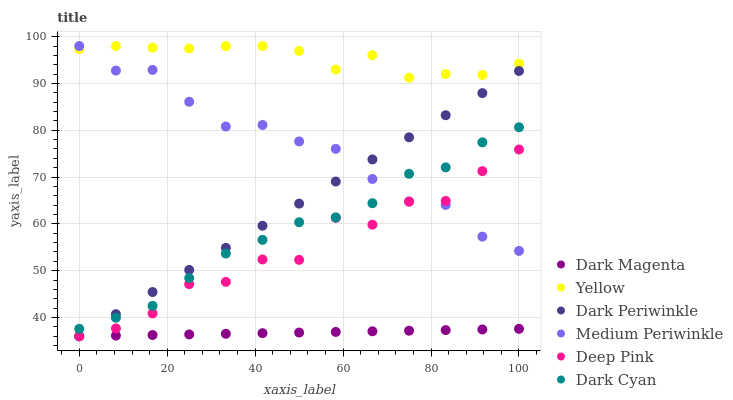Does Dark Magenta have the minimum area under the curve?
Answer yes or no. Yes. Does Yellow have the maximum area under the curve?
Answer yes or no. Yes. Does Medium Periwinkle have the minimum area under the curve?
Answer yes or no. No. Does Medium Periwinkle have the maximum area under the curve?
Answer yes or no. No. Is Dark Magenta the smoothest?
Answer yes or no. Yes. Is Deep Pink the roughest?
Answer yes or no. Yes. Is Medium Periwinkle the smoothest?
Answer yes or no. No. Is Medium Periwinkle the roughest?
Answer yes or no. No. Does Deep Pink have the lowest value?
Answer yes or no. Yes. Does Medium Periwinkle have the lowest value?
Answer yes or no. No. Does Yellow have the highest value?
Answer yes or no. Yes. Does Dark Magenta have the highest value?
Answer yes or no. No. Is Dark Cyan less than Yellow?
Answer yes or no. Yes. Is Medium Periwinkle greater than Dark Magenta?
Answer yes or no. Yes. Does Dark Periwinkle intersect Dark Cyan?
Answer yes or no. Yes. Is Dark Periwinkle less than Dark Cyan?
Answer yes or no. No. Is Dark Periwinkle greater than Dark Cyan?
Answer yes or no. No. Does Dark Cyan intersect Yellow?
Answer yes or no. No. 